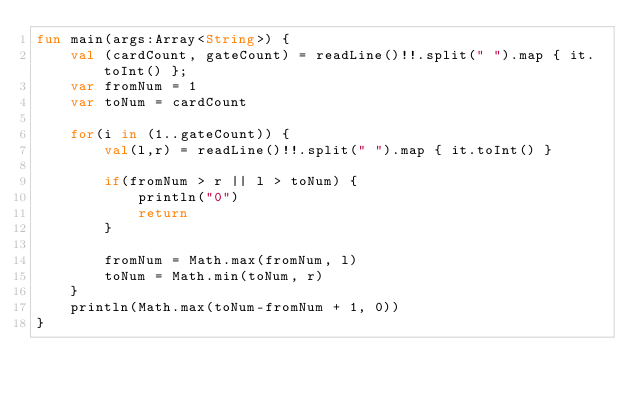<code> <loc_0><loc_0><loc_500><loc_500><_Kotlin_>fun main(args:Array<String>) {
    val (cardCount, gateCount) = readLine()!!.split(" ").map { it.toInt() };
    var fromNum = 1
    var toNum = cardCount

    for(i in (1..gateCount)) {
        val(l,r) = readLine()!!.split(" ").map { it.toInt() }

        if(fromNum > r || l > toNum) {
            println("0")
            return
        }

        fromNum = Math.max(fromNum, l)
        toNum = Math.min(toNum, r)
    }
    println(Math.max(toNum-fromNum + 1, 0))
}
</code> 